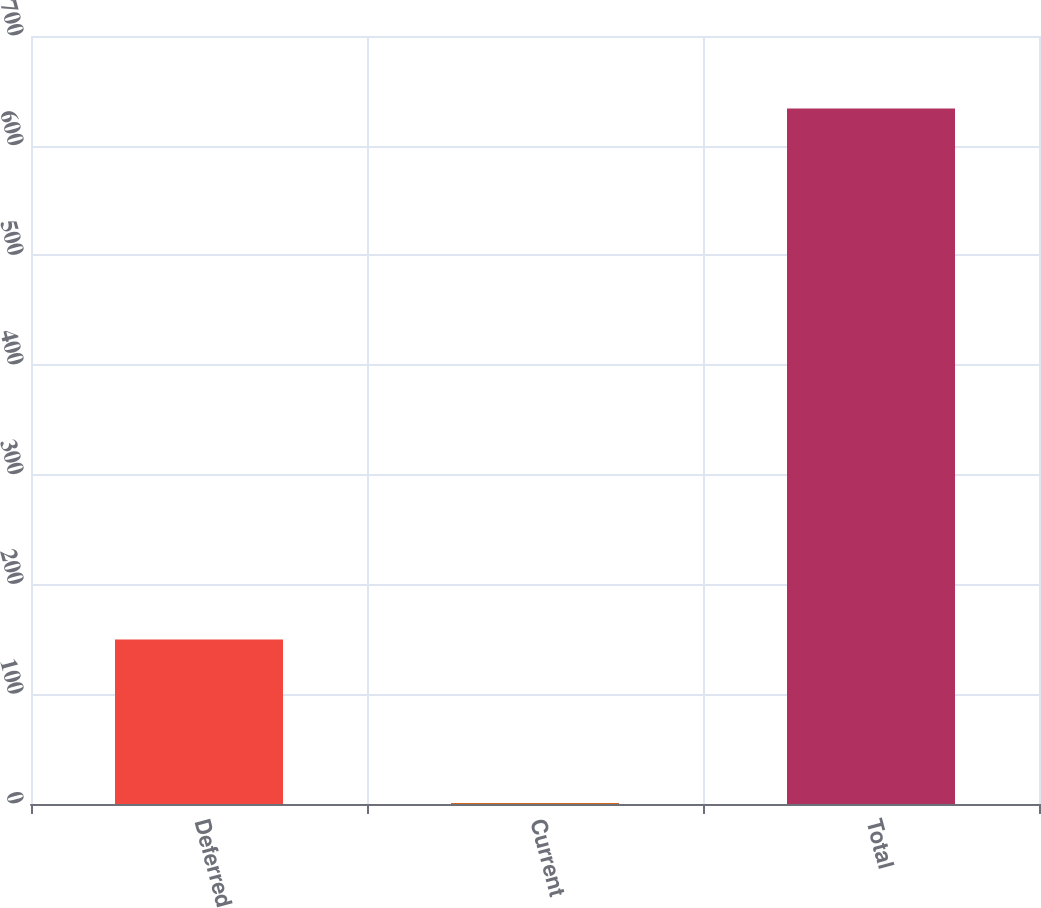Convert chart to OTSL. <chart><loc_0><loc_0><loc_500><loc_500><bar_chart><fcel>Deferred<fcel>Current<fcel>Total<nl><fcel>150<fcel>1<fcel>634<nl></chart> 